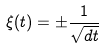<formula> <loc_0><loc_0><loc_500><loc_500>\xi ( t ) = \pm \frac { 1 } { \sqrt { d t } }</formula> 